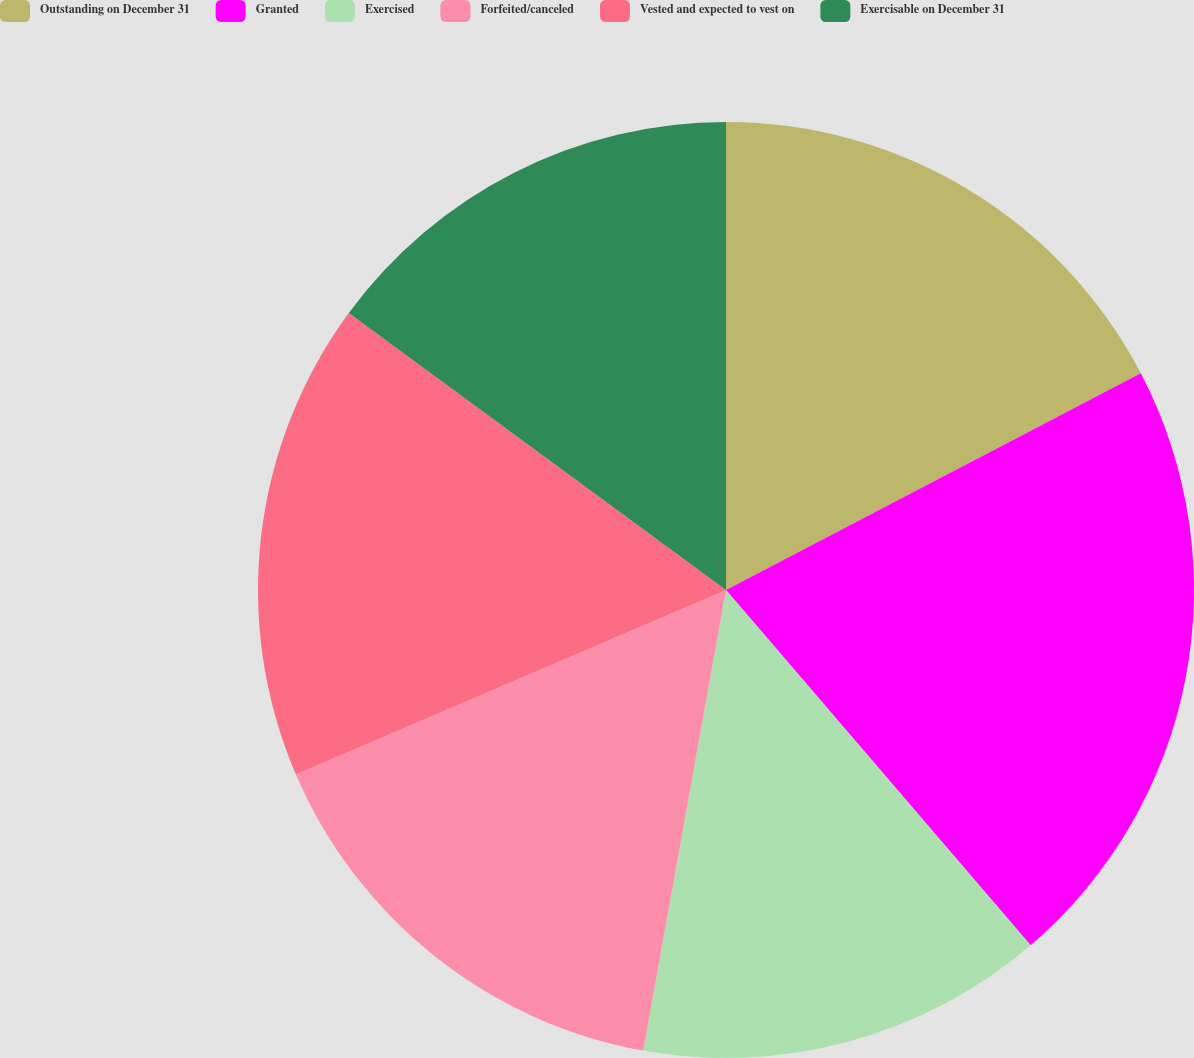<chart> <loc_0><loc_0><loc_500><loc_500><pie_chart><fcel>Outstanding on December 31<fcel>Granted<fcel>Exercised<fcel>Forfeited/canceled<fcel>Vested and expected to vest on<fcel>Exercisable on December 31<nl><fcel>17.34%<fcel>21.38%<fcel>14.11%<fcel>15.72%<fcel>16.53%<fcel>14.92%<nl></chart> 